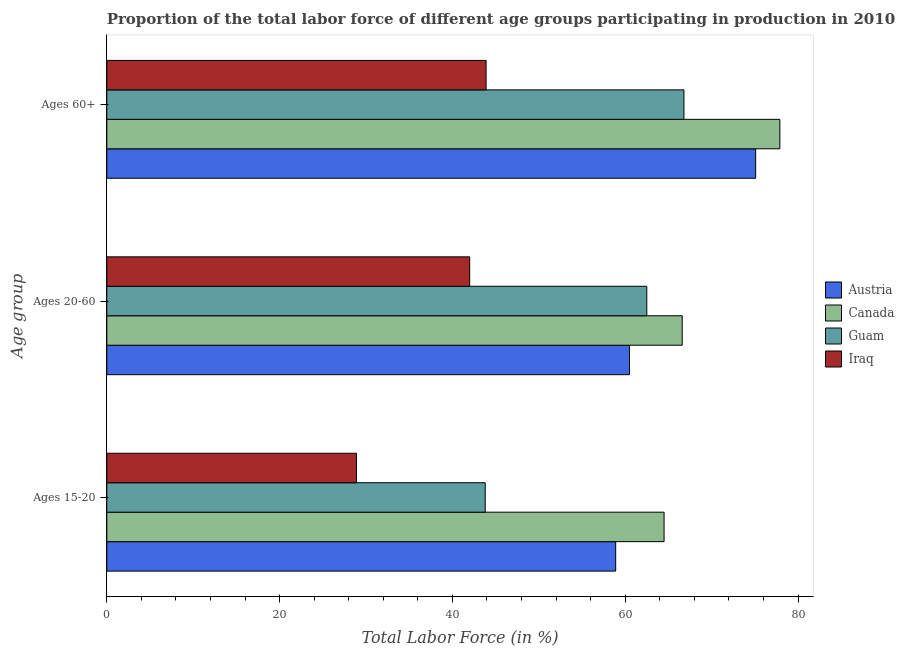How many different coloured bars are there?
Make the answer very short. 4. How many groups of bars are there?
Your response must be concise. 3. Are the number of bars per tick equal to the number of legend labels?
Your answer should be compact. Yes. Are the number of bars on each tick of the Y-axis equal?
Keep it short and to the point. Yes. How many bars are there on the 2nd tick from the bottom?
Provide a succinct answer. 4. What is the label of the 1st group of bars from the top?
Provide a short and direct response. Ages 60+. What is the percentage of labor force within the age group 20-60 in Guam?
Give a very brief answer. 62.5. Across all countries, what is the maximum percentage of labor force within the age group 15-20?
Offer a very short reply. 64.5. Across all countries, what is the minimum percentage of labor force within the age group 20-60?
Your answer should be compact. 42. In which country was the percentage of labor force above age 60 minimum?
Make the answer very short. Iraq. What is the total percentage of labor force above age 60 in the graph?
Offer a terse response. 263.7. What is the difference between the percentage of labor force within the age group 15-20 in Guam and that in Austria?
Your response must be concise. -15.1. What is the difference between the percentage of labor force within the age group 20-60 in Iraq and the percentage of labor force above age 60 in Austria?
Provide a succinct answer. -33.1. What is the average percentage of labor force within the age group 20-60 per country?
Make the answer very short. 57.9. What is the difference between the percentage of labor force within the age group 20-60 and percentage of labor force above age 60 in Iraq?
Make the answer very short. -1.9. What is the ratio of the percentage of labor force above age 60 in Guam to that in Canada?
Provide a succinct answer. 0.86. Is the difference between the percentage of labor force within the age group 20-60 in Canada and Austria greater than the difference between the percentage of labor force above age 60 in Canada and Austria?
Your response must be concise. Yes. What is the difference between the highest and the second highest percentage of labor force within the age group 20-60?
Keep it short and to the point. 4.1. What is the difference between the highest and the lowest percentage of labor force above age 60?
Your response must be concise. 34. Is the sum of the percentage of labor force within the age group 15-20 in Iraq and Austria greater than the maximum percentage of labor force within the age group 20-60 across all countries?
Give a very brief answer. Yes. What does the 1st bar from the top in Ages 15-20 represents?
Your answer should be compact. Iraq. What does the 3rd bar from the bottom in Ages 15-20 represents?
Your answer should be very brief. Guam. Is it the case that in every country, the sum of the percentage of labor force within the age group 15-20 and percentage of labor force within the age group 20-60 is greater than the percentage of labor force above age 60?
Your answer should be very brief. Yes. Does the graph contain any zero values?
Your answer should be compact. No. Where does the legend appear in the graph?
Your answer should be compact. Center right. What is the title of the graph?
Ensure brevity in your answer.  Proportion of the total labor force of different age groups participating in production in 2010. What is the label or title of the Y-axis?
Your answer should be compact. Age group. What is the Total Labor Force (in %) in Austria in Ages 15-20?
Offer a very short reply. 58.9. What is the Total Labor Force (in %) of Canada in Ages 15-20?
Ensure brevity in your answer.  64.5. What is the Total Labor Force (in %) of Guam in Ages 15-20?
Provide a short and direct response. 43.8. What is the Total Labor Force (in %) of Iraq in Ages 15-20?
Your answer should be very brief. 28.9. What is the Total Labor Force (in %) in Austria in Ages 20-60?
Provide a short and direct response. 60.5. What is the Total Labor Force (in %) in Canada in Ages 20-60?
Your answer should be compact. 66.6. What is the Total Labor Force (in %) in Guam in Ages 20-60?
Keep it short and to the point. 62.5. What is the Total Labor Force (in %) of Austria in Ages 60+?
Offer a terse response. 75.1. What is the Total Labor Force (in %) in Canada in Ages 60+?
Offer a very short reply. 77.9. What is the Total Labor Force (in %) in Guam in Ages 60+?
Give a very brief answer. 66.8. What is the Total Labor Force (in %) in Iraq in Ages 60+?
Your response must be concise. 43.9. Across all Age group, what is the maximum Total Labor Force (in %) of Austria?
Provide a short and direct response. 75.1. Across all Age group, what is the maximum Total Labor Force (in %) in Canada?
Offer a very short reply. 77.9. Across all Age group, what is the maximum Total Labor Force (in %) in Guam?
Keep it short and to the point. 66.8. Across all Age group, what is the maximum Total Labor Force (in %) of Iraq?
Provide a short and direct response. 43.9. Across all Age group, what is the minimum Total Labor Force (in %) of Austria?
Your answer should be compact. 58.9. Across all Age group, what is the minimum Total Labor Force (in %) of Canada?
Make the answer very short. 64.5. Across all Age group, what is the minimum Total Labor Force (in %) of Guam?
Offer a terse response. 43.8. Across all Age group, what is the minimum Total Labor Force (in %) of Iraq?
Make the answer very short. 28.9. What is the total Total Labor Force (in %) in Austria in the graph?
Give a very brief answer. 194.5. What is the total Total Labor Force (in %) in Canada in the graph?
Provide a succinct answer. 209. What is the total Total Labor Force (in %) of Guam in the graph?
Make the answer very short. 173.1. What is the total Total Labor Force (in %) in Iraq in the graph?
Your response must be concise. 114.8. What is the difference between the Total Labor Force (in %) of Guam in Ages 15-20 and that in Ages 20-60?
Your response must be concise. -18.7. What is the difference between the Total Labor Force (in %) in Iraq in Ages 15-20 and that in Ages 20-60?
Keep it short and to the point. -13.1. What is the difference between the Total Labor Force (in %) in Austria in Ages 15-20 and that in Ages 60+?
Your answer should be very brief. -16.2. What is the difference between the Total Labor Force (in %) in Guam in Ages 15-20 and that in Ages 60+?
Provide a succinct answer. -23. What is the difference between the Total Labor Force (in %) of Iraq in Ages 15-20 and that in Ages 60+?
Make the answer very short. -15. What is the difference between the Total Labor Force (in %) in Austria in Ages 20-60 and that in Ages 60+?
Your answer should be compact. -14.6. What is the difference between the Total Labor Force (in %) in Guam in Ages 20-60 and that in Ages 60+?
Give a very brief answer. -4.3. What is the difference between the Total Labor Force (in %) in Austria in Ages 15-20 and the Total Labor Force (in %) in Iraq in Ages 20-60?
Provide a succinct answer. 16.9. What is the difference between the Total Labor Force (in %) in Canada in Ages 15-20 and the Total Labor Force (in %) in Guam in Ages 20-60?
Give a very brief answer. 2. What is the difference between the Total Labor Force (in %) of Canada in Ages 15-20 and the Total Labor Force (in %) of Iraq in Ages 20-60?
Make the answer very short. 22.5. What is the difference between the Total Labor Force (in %) of Austria in Ages 15-20 and the Total Labor Force (in %) of Canada in Ages 60+?
Provide a succinct answer. -19. What is the difference between the Total Labor Force (in %) of Austria in Ages 15-20 and the Total Labor Force (in %) of Iraq in Ages 60+?
Provide a short and direct response. 15. What is the difference between the Total Labor Force (in %) of Canada in Ages 15-20 and the Total Labor Force (in %) of Iraq in Ages 60+?
Your response must be concise. 20.6. What is the difference between the Total Labor Force (in %) of Austria in Ages 20-60 and the Total Labor Force (in %) of Canada in Ages 60+?
Make the answer very short. -17.4. What is the difference between the Total Labor Force (in %) of Austria in Ages 20-60 and the Total Labor Force (in %) of Iraq in Ages 60+?
Ensure brevity in your answer.  16.6. What is the difference between the Total Labor Force (in %) of Canada in Ages 20-60 and the Total Labor Force (in %) of Iraq in Ages 60+?
Your answer should be compact. 22.7. What is the difference between the Total Labor Force (in %) in Guam in Ages 20-60 and the Total Labor Force (in %) in Iraq in Ages 60+?
Provide a short and direct response. 18.6. What is the average Total Labor Force (in %) in Austria per Age group?
Give a very brief answer. 64.83. What is the average Total Labor Force (in %) of Canada per Age group?
Your answer should be very brief. 69.67. What is the average Total Labor Force (in %) in Guam per Age group?
Keep it short and to the point. 57.7. What is the average Total Labor Force (in %) in Iraq per Age group?
Offer a terse response. 38.27. What is the difference between the Total Labor Force (in %) in Canada and Total Labor Force (in %) in Guam in Ages 15-20?
Give a very brief answer. 20.7. What is the difference between the Total Labor Force (in %) in Canada and Total Labor Force (in %) in Iraq in Ages 15-20?
Offer a terse response. 35.6. What is the difference between the Total Labor Force (in %) in Guam and Total Labor Force (in %) in Iraq in Ages 15-20?
Make the answer very short. 14.9. What is the difference between the Total Labor Force (in %) in Austria and Total Labor Force (in %) in Iraq in Ages 20-60?
Offer a terse response. 18.5. What is the difference between the Total Labor Force (in %) of Canada and Total Labor Force (in %) of Guam in Ages 20-60?
Provide a short and direct response. 4.1. What is the difference between the Total Labor Force (in %) in Canada and Total Labor Force (in %) in Iraq in Ages 20-60?
Make the answer very short. 24.6. What is the difference between the Total Labor Force (in %) in Austria and Total Labor Force (in %) in Canada in Ages 60+?
Offer a very short reply. -2.8. What is the difference between the Total Labor Force (in %) of Austria and Total Labor Force (in %) of Guam in Ages 60+?
Your answer should be compact. 8.3. What is the difference between the Total Labor Force (in %) in Austria and Total Labor Force (in %) in Iraq in Ages 60+?
Give a very brief answer. 31.2. What is the difference between the Total Labor Force (in %) of Canada and Total Labor Force (in %) of Iraq in Ages 60+?
Your answer should be very brief. 34. What is the difference between the Total Labor Force (in %) in Guam and Total Labor Force (in %) in Iraq in Ages 60+?
Offer a very short reply. 22.9. What is the ratio of the Total Labor Force (in %) of Austria in Ages 15-20 to that in Ages 20-60?
Offer a very short reply. 0.97. What is the ratio of the Total Labor Force (in %) in Canada in Ages 15-20 to that in Ages 20-60?
Your answer should be compact. 0.97. What is the ratio of the Total Labor Force (in %) of Guam in Ages 15-20 to that in Ages 20-60?
Offer a very short reply. 0.7. What is the ratio of the Total Labor Force (in %) of Iraq in Ages 15-20 to that in Ages 20-60?
Your answer should be compact. 0.69. What is the ratio of the Total Labor Force (in %) of Austria in Ages 15-20 to that in Ages 60+?
Give a very brief answer. 0.78. What is the ratio of the Total Labor Force (in %) of Canada in Ages 15-20 to that in Ages 60+?
Your answer should be compact. 0.83. What is the ratio of the Total Labor Force (in %) in Guam in Ages 15-20 to that in Ages 60+?
Offer a very short reply. 0.66. What is the ratio of the Total Labor Force (in %) of Iraq in Ages 15-20 to that in Ages 60+?
Provide a succinct answer. 0.66. What is the ratio of the Total Labor Force (in %) of Austria in Ages 20-60 to that in Ages 60+?
Provide a short and direct response. 0.81. What is the ratio of the Total Labor Force (in %) in Canada in Ages 20-60 to that in Ages 60+?
Provide a short and direct response. 0.85. What is the ratio of the Total Labor Force (in %) of Guam in Ages 20-60 to that in Ages 60+?
Ensure brevity in your answer.  0.94. What is the ratio of the Total Labor Force (in %) of Iraq in Ages 20-60 to that in Ages 60+?
Your response must be concise. 0.96. What is the difference between the highest and the second highest Total Labor Force (in %) in Canada?
Your answer should be very brief. 11.3. What is the difference between the highest and the second highest Total Labor Force (in %) in Guam?
Provide a short and direct response. 4.3. What is the difference between the highest and the lowest Total Labor Force (in %) in Austria?
Offer a very short reply. 16.2. What is the difference between the highest and the lowest Total Labor Force (in %) of Canada?
Your answer should be compact. 13.4. 